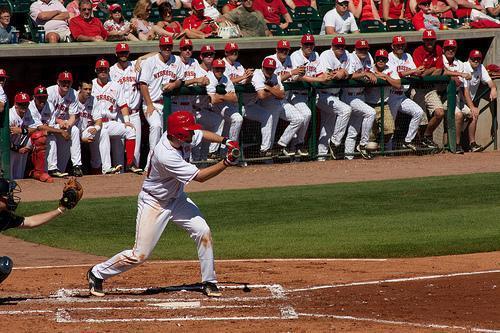How many batting gloves is the man wearing?
Give a very brief answer. 2. 